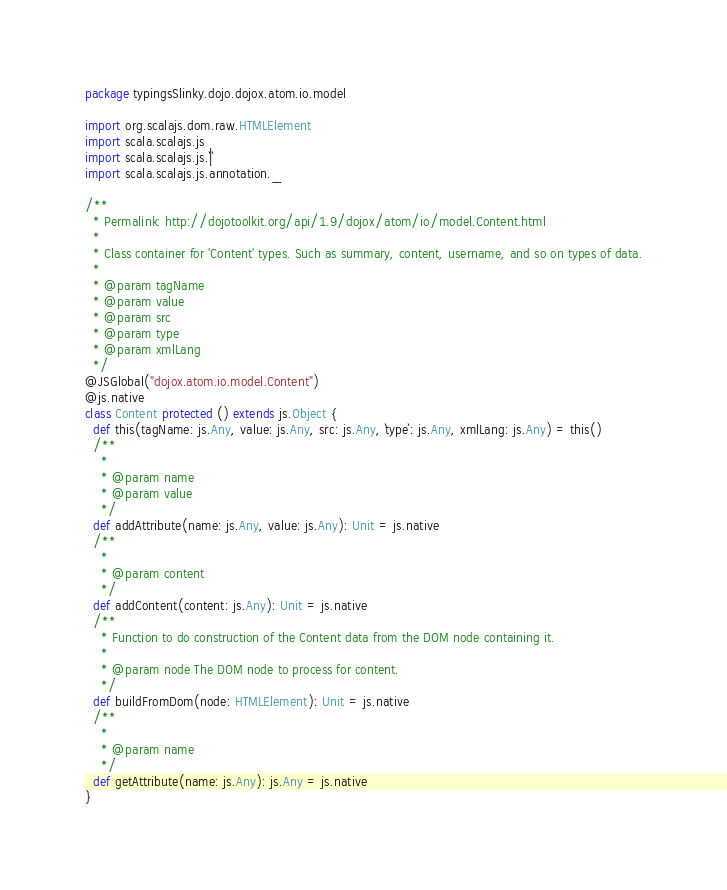<code> <loc_0><loc_0><loc_500><loc_500><_Scala_>package typingsSlinky.dojo.dojox.atom.io.model

import org.scalajs.dom.raw.HTMLElement
import scala.scalajs.js
import scala.scalajs.js.`|`
import scala.scalajs.js.annotation._

/**
  * Permalink: http://dojotoolkit.org/api/1.9/dojox/atom/io/model.Content.html
  *
  * Class container for 'Content' types. Such as summary, content, username, and so on types of data.
  *
  * @param tagName
  * @param value
  * @param src
  * @param type
  * @param xmlLang
  */
@JSGlobal("dojox.atom.io.model.Content")
@js.native
class Content protected () extends js.Object {
  def this(tagName: js.Any, value: js.Any, src: js.Any, `type`: js.Any, xmlLang: js.Any) = this()
  /**
    *
    * @param name
    * @param value
    */
  def addAttribute(name: js.Any, value: js.Any): Unit = js.native
  /**
    *
    * @param content
    */
  def addContent(content: js.Any): Unit = js.native
  /**
    * Function to do construction of the Content data from the DOM node containing it.
    *
    * @param node The DOM node to process for content.
    */
  def buildFromDom(node: HTMLElement): Unit = js.native
  /**
    *
    * @param name
    */
  def getAttribute(name: js.Any): js.Any = js.native
}

</code> 